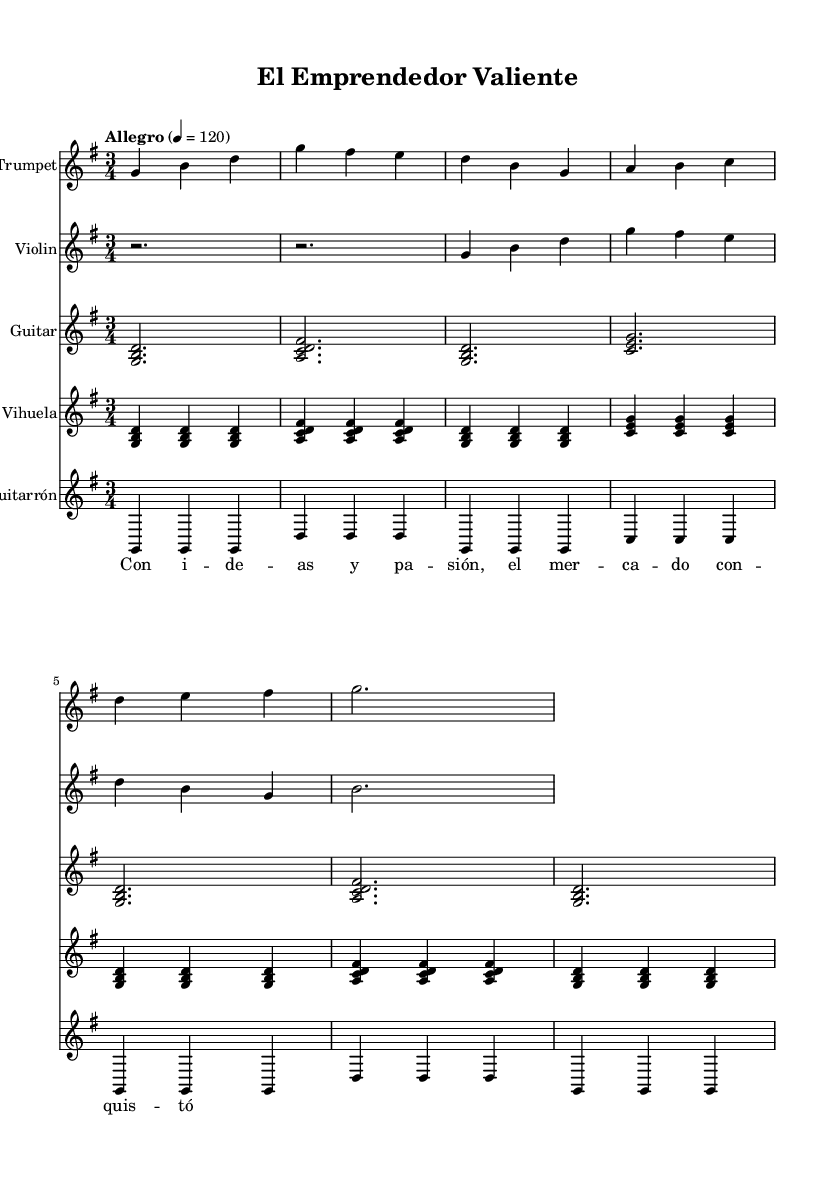What is the key signature of this music? The key signature is G major, which has one sharp (F#). This can be identified by looking for the key signature indicator at the beginning of the staff.
Answer: G major What is the time signature of this piece? The time signature is 3/4, which can be found next to the key signature at the beginning of the staff. It indicates that there are three beats per measure, and the quarter note gets one beat.
Answer: 3/4 What is the tempo marking of the music? The tempo marking indicates "Allegro," which means a fast and lively tempo, and it shows a metronomic indication of 120 beats per minute. This can be observed in the tempo designation above the staff.
Answer: Allegro How many measures are in the trumpet part? The trumpet part consists of 7 measures, as seen by counting the groupings of vertical lines (bar lines) in the trumpet staff. Each bar line separates one measure from the next.
Answer: 7 Which instrument plays a sustained note in the second measure? The violin plays a sustained rest in the second measure, indicated by the symbol for silence that is present for the entirety of that measure.
Answer: Violin What harmonic structure does the guitar primarily use? The guitar mainly uses triads, which are three-note chords, as indicated by the chord shapes shown (for example, G major, A major) that form the harmonic backdrop of the melody.
Answer: Triads What lyrical theme is represented in the song? The lyrics suggest themes of entrepreneurship and passion, as indicated by the text stating "Con ideas y pasión, el mercado conquistó," reflecting aspects of innovation and commerce.
Answer: Entrepreneurship 